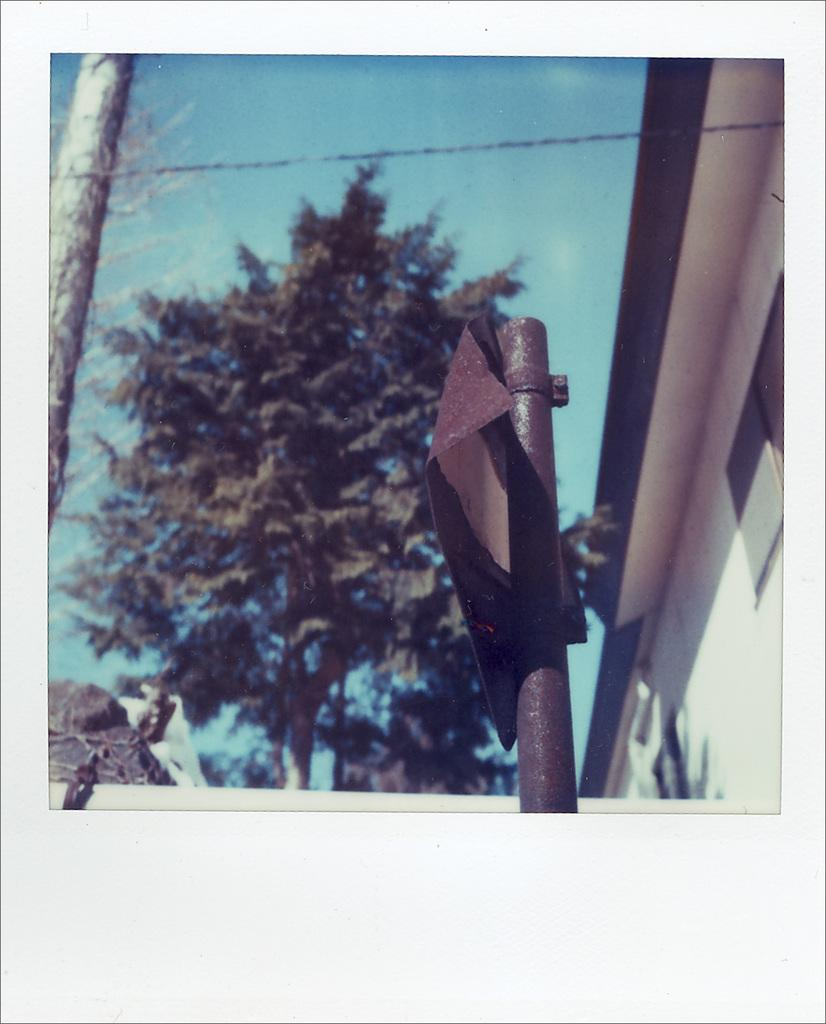What is the main object in the foreground of the image? There is a pole in the image. What can be seen in the background of the image? There are green trees and a cream-colored building in the background of the image. What color is the sky in the image? The sky is blue in the image. What type of watch is the person wearing in the image? There is no person wearing a watch in the image; it only features a pole, trees, a building, and the sky. What meal is being prepared in the image? There is no meal preparation visible in the image; it only features a pole, trees, a building, and the sky. 